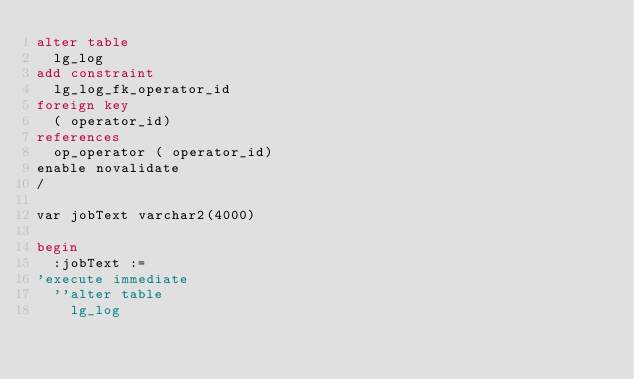<code> <loc_0><loc_0><loc_500><loc_500><_SQL_>alter table
  lg_log
add constraint
  lg_log_fk_operator_id
foreign key
  ( operator_id)
references
  op_operator ( operator_id)
enable novalidate
/

var jobText varchar2(4000)

begin
  :jobText :=
'execute immediate
  ''alter table
    lg_log</code> 